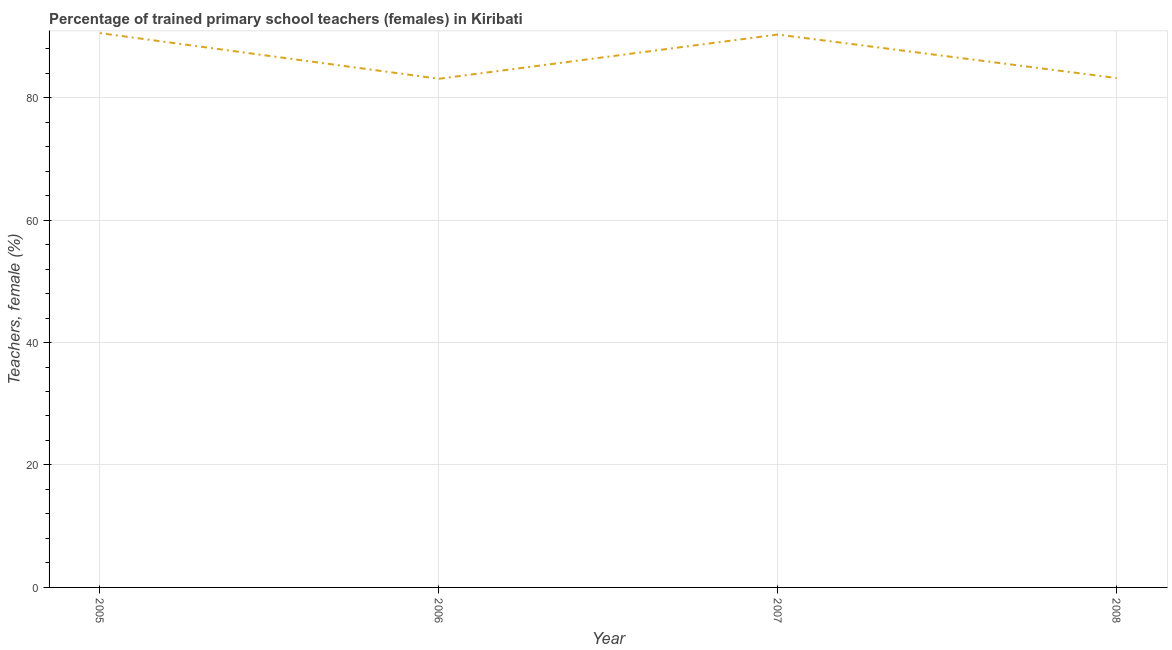What is the percentage of trained female teachers in 2006?
Keep it short and to the point. 83.08. Across all years, what is the maximum percentage of trained female teachers?
Make the answer very short. 90.53. Across all years, what is the minimum percentage of trained female teachers?
Make the answer very short. 83.08. In which year was the percentage of trained female teachers minimum?
Keep it short and to the point. 2006. What is the sum of the percentage of trained female teachers?
Make the answer very short. 347.1. What is the difference between the percentage of trained female teachers in 2005 and 2007?
Make the answer very short. 0.23. What is the average percentage of trained female teachers per year?
Make the answer very short. 86.78. What is the median percentage of trained female teachers?
Offer a terse response. 86.75. In how many years, is the percentage of trained female teachers greater than 44 %?
Provide a short and direct response. 4. Do a majority of the years between 2005 and 2007 (inclusive) have percentage of trained female teachers greater than 44 %?
Make the answer very short. Yes. What is the ratio of the percentage of trained female teachers in 2006 to that in 2007?
Your answer should be very brief. 0.92. Is the percentage of trained female teachers in 2005 less than that in 2008?
Provide a succinct answer. No. What is the difference between the highest and the second highest percentage of trained female teachers?
Your response must be concise. 0.23. Is the sum of the percentage of trained female teachers in 2005 and 2006 greater than the maximum percentage of trained female teachers across all years?
Provide a short and direct response. Yes. What is the difference between the highest and the lowest percentage of trained female teachers?
Offer a terse response. 7.46. In how many years, is the percentage of trained female teachers greater than the average percentage of trained female teachers taken over all years?
Your answer should be compact. 2. How many years are there in the graph?
Keep it short and to the point. 4. What is the difference between two consecutive major ticks on the Y-axis?
Keep it short and to the point. 20. What is the title of the graph?
Your answer should be very brief. Percentage of trained primary school teachers (females) in Kiribati. What is the label or title of the Y-axis?
Your response must be concise. Teachers, female (%). What is the Teachers, female (%) in 2005?
Make the answer very short. 90.53. What is the Teachers, female (%) in 2006?
Your response must be concise. 83.08. What is the Teachers, female (%) in 2007?
Provide a succinct answer. 90.3. What is the Teachers, female (%) of 2008?
Make the answer very short. 83.19. What is the difference between the Teachers, female (%) in 2005 and 2006?
Your answer should be very brief. 7.46. What is the difference between the Teachers, female (%) in 2005 and 2007?
Ensure brevity in your answer.  0.23. What is the difference between the Teachers, female (%) in 2005 and 2008?
Your answer should be compact. 7.34. What is the difference between the Teachers, female (%) in 2006 and 2007?
Keep it short and to the point. -7.22. What is the difference between the Teachers, female (%) in 2006 and 2008?
Your response must be concise. -0.12. What is the difference between the Teachers, female (%) in 2007 and 2008?
Your response must be concise. 7.11. What is the ratio of the Teachers, female (%) in 2005 to that in 2006?
Your response must be concise. 1.09. What is the ratio of the Teachers, female (%) in 2005 to that in 2008?
Your answer should be very brief. 1.09. What is the ratio of the Teachers, female (%) in 2007 to that in 2008?
Provide a succinct answer. 1.08. 